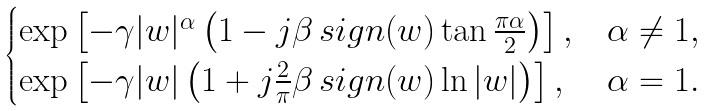Convert formula to latex. <formula><loc_0><loc_0><loc_500><loc_500>\begin{cases} \exp \left [ - \gamma | w | ^ { \alpha } \left ( 1 - j \beta \, s i g n ( w ) \tan \frac { \pi \alpha } { 2 } \right ) \right ] , & \alpha \neq 1 , \\ \exp \left [ - \gamma | w | \left ( 1 + j \frac { 2 } { \pi } \beta \, s i g n ( w ) \ln | w | \right ) \right ] , & \alpha = 1 . \end{cases}</formula> 